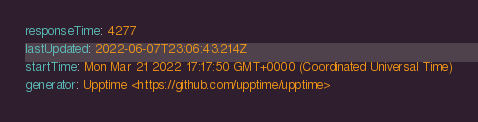<code> <loc_0><loc_0><loc_500><loc_500><_YAML_>responseTime: 4277
lastUpdated: 2022-06-07T23:06:43.214Z
startTime: Mon Mar 21 2022 17:17:50 GMT+0000 (Coordinated Universal Time)
generator: Upptime <https://github.com/upptime/upptime>
</code> 